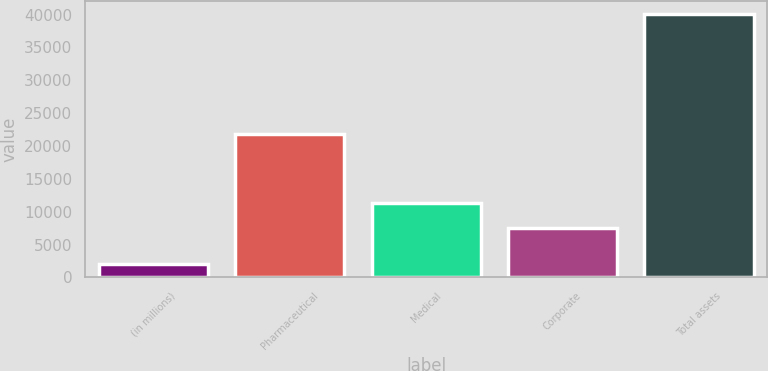Convert chart to OTSL. <chart><loc_0><loc_0><loc_500><loc_500><bar_chart><fcel>(in millions)<fcel>Pharmaceutical<fcel>Medical<fcel>Corporate<fcel>Total assets<nl><fcel>2017<fcel>21848<fcel>11385.5<fcel>7576<fcel>40112<nl></chart> 